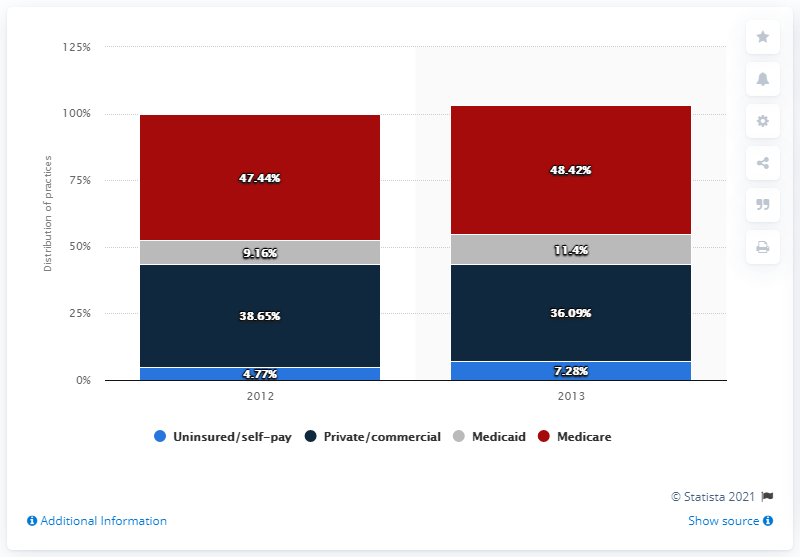Draw attention to some important aspects in this diagram. The total number of uninsured or self-pay patients is 12.05. Uninsured/self-pay patients are the category of payers that are least likely to pay their medical bills in full or on time. 